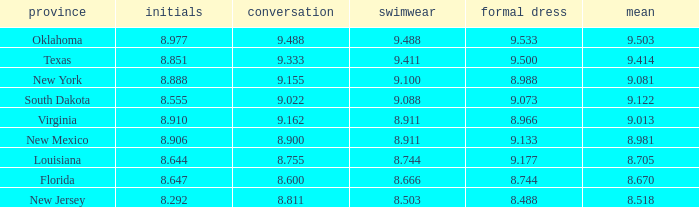 what's the preliminaries where evening gown is 8.988 8.888. 